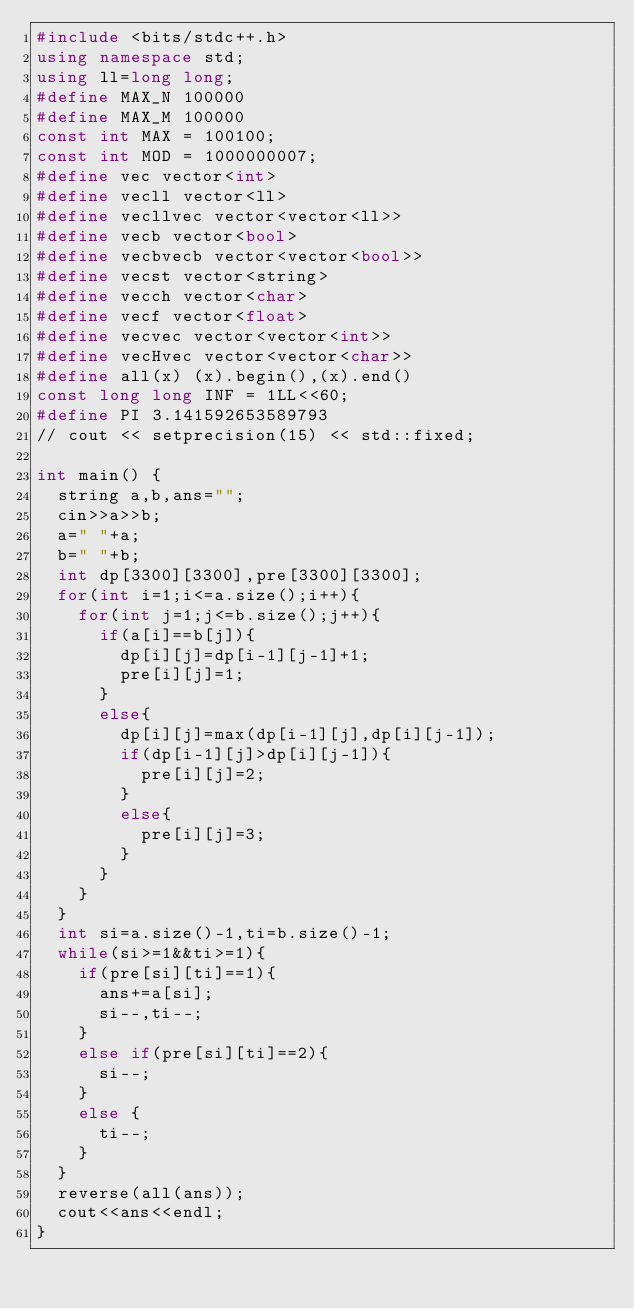<code> <loc_0><loc_0><loc_500><loc_500><_C++_>#include <bits/stdc++.h>
using namespace std;
using ll=long long;
#define MAX_N 100000
#define MAX_M 100000
const int MAX = 100100;
const int MOD = 1000000007;
#define vec vector<int>
#define vecll vector<ll>
#define vecllvec vector<vector<ll>>
#define vecb vector<bool>
#define vecbvecb vector<vector<bool>>
#define vecst vector<string>
#define vecch vector<char>
#define vecf vector<float>
#define vecvec vector<vector<int>>
#define vecHvec vector<vector<char>>
#define all(x) (x).begin(),(x).end()
const long long INF = 1LL<<60;
#define PI 3.141592653589793
// cout << setprecision(15) << std::fixed;

int main() {
  string a,b,ans="";
  cin>>a>>b;
  a=" "+a;
  b=" "+b;
  int dp[3300][3300],pre[3300][3300];
  for(int i=1;i<=a.size();i++){
    for(int j=1;j<=b.size();j++){
      if(a[i]==b[j]){
        dp[i][j]=dp[i-1][j-1]+1;
        pre[i][j]=1;
      }
      else{
        dp[i][j]=max(dp[i-1][j],dp[i][j-1]);
        if(dp[i-1][j]>dp[i][j-1]){
          pre[i][j]=2;
        }
        else{
          pre[i][j]=3;
        }
      }
    }
  }
  int si=a.size()-1,ti=b.size()-1;
  while(si>=1&&ti>=1){
    if(pre[si][ti]==1){
      ans+=a[si];
      si--,ti--;
    }
    else if(pre[si][ti]==2){
      si--;
    }
    else {
      ti--;
    }
  }
  reverse(all(ans));
  cout<<ans<<endl;
}
</code> 